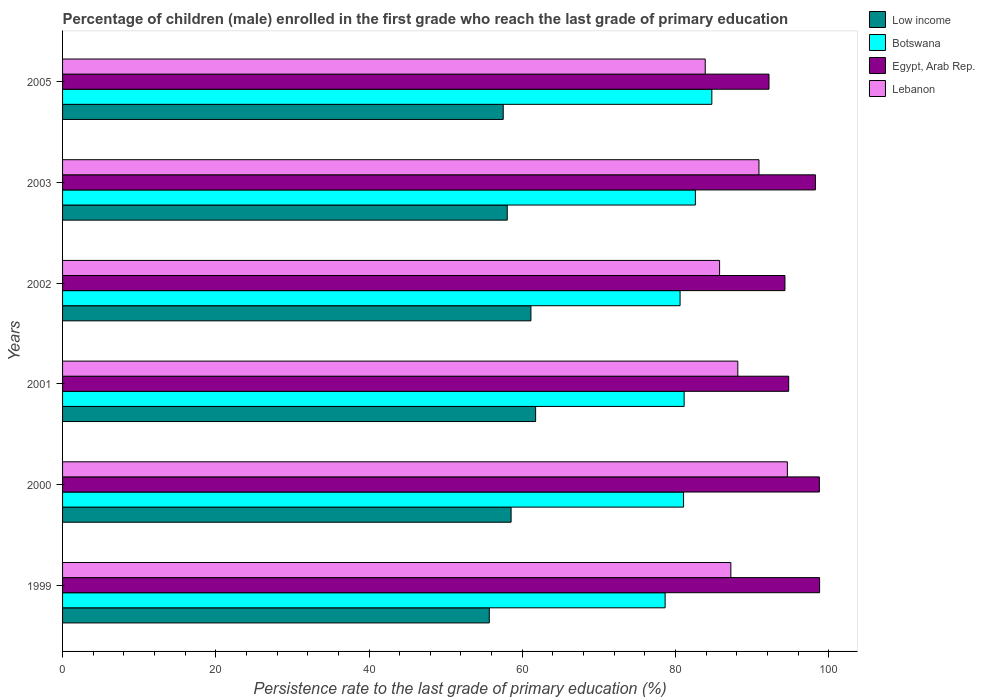How many different coloured bars are there?
Ensure brevity in your answer.  4. Are the number of bars on each tick of the Y-axis equal?
Make the answer very short. Yes. How many bars are there on the 4th tick from the top?
Provide a succinct answer. 4. How many bars are there on the 3rd tick from the bottom?
Your answer should be very brief. 4. In how many cases, is the number of bars for a given year not equal to the number of legend labels?
Offer a terse response. 0. What is the persistence rate of children in Egypt, Arab Rep. in 2000?
Your answer should be compact. 98.78. Across all years, what is the maximum persistence rate of children in Egypt, Arab Rep.?
Make the answer very short. 98.81. Across all years, what is the minimum persistence rate of children in Egypt, Arab Rep.?
Keep it short and to the point. 92.2. In which year was the persistence rate of children in Low income maximum?
Ensure brevity in your answer.  2001. What is the total persistence rate of children in Botswana in the graph?
Your answer should be compact. 488.74. What is the difference between the persistence rate of children in Botswana in 2003 and that in 2005?
Offer a terse response. -2.15. What is the difference between the persistence rate of children in Low income in 2005 and the persistence rate of children in Lebanon in 2000?
Offer a very short reply. -37.09. What is the average persistence rate of children in Egypt, Arab Rep. per year?
Your response must be concise. 96.18. In the year 2000, what is the difference between the persistence rate of children in Low income and persistence rate of children in Egypt, Arab Rep.?
Give a very brief answer. -40.24. What is the ratio of the persistence rate of children in Botswana in 1999 to that in 2001?
Your answer should be very brief. 0.97. What is the difference between the highest and the second highest persistence rate of children in Egypt, Arab Rep.?
Give a very brief answer. 0.03. What is the difference between the highest and the lowest persistence rate of children in Lebanon?
Offer a very short reply. 10.72. In how many years, is the persistence rate of children in Egypt, Arab Rep. greater than the average persistence rate of children in Egypt, Arab Rep. taken over all years?
Your response must be concise. 3. What does the 2nd bar from the top in 2001 represents?
Your response must be concise. Egypt, Arab Rep. What does the 2nd bar from the bottom in 2005 represents?
Provide a short and direct response. Botswana. What is the difference between two consecutive major ticks on the X-axis?
Offer a terse response. 20. Does the graph contain any zero values?
Your answer should be compact. No. How many legend labels are there?
Your response must be concise. 4. What is the title of the graph?
Provide a succinct answer. Percentage of children (male) enrolled in the first grade who reach the last grade of primary education. What is the label or title of the X-axis?
Keep it short and to the point. Persistence rate to the last grade of primary education (%). What is the Persistence rate to the last grade of primary education (%) of Low income in 1999?
Give a very brief answer. 55.7. What is the Persistence rate to the last grade of primary education (%) in Botswana in 1999?
Keep it short and to the point. 78.64. What is the Persistence rate to the last grade of primary education (%) in Egypt, Arab Rep. in 1999?
Give a very brief answer. 98.81. What is the Persistence rate to the last grade of primary education (%) of Lebanon in 1999?
Provide a short and direct response. 87.22. What is the Persistence rate to the last grade of primary education (%) of Low income in 2000?
Make the answer very short. 58.54. What is the Persistence rate to the last grade of primary education (%) of Botswana in 2000?
Provide a succinct answer. 81.05. What is the Persistence rate to the last grade of primary education (%) in Egypt, Arab Rep. in 2000?
Offer a terse response. 98.78. What is the Persistence rate to the last grade of primary education (%) of Lebanon in 2000?
Offer a very short reply. 94.6. What is the Persistence rate to the last grade of primary education (%) of Low income in 2001?
Your answer should be compact. 61.74. What is the Persistence rate to the last grade of primary education (%) of Botswana in 2001?
Offer a terse response. 81.12. What is the Persistence rate to the last grade of primary education (%) in Egypt, Arab Rep. in 2001?
Your response must be concise. 94.77. What is the Persistence rate to the last grade of primary education (%) in Lebanon in 2001?
Give a very brief answer. 88.13. What is the Persistence rate to the last grade of primary education (%) of Low income in 2002?
Give a very brief answer. 61.13. What is the Persistence rate to the last grade of primary education (%) in Botswana in 2002?
Give a very brief answer. 80.59. What is the Persistence rate to the last grade of primary education (%) of Egypt, Arab Rep. in 2002?
Offer a terse response. 94.28. What is the Persistence rate to the last grade of primary education (%) in Lebanon in 2002?
Give a very brief answer. 85.75. What is the Persistence rate to the last grade of primary education (%) of Low income in 2003?
Provide a succinct answer. 58.04. What is the Persistence rate to the last grade of primary education (%) in Botswana in 2003?
Give a very brief answer. 82.59. What is the Persistence rate to the last grade of primary education (%) in Egypt, Arab Rep. in 2003?
Offer a very short reply. 98.26. What is the Persistence rate to the last grade of primary education (%) in Lebanon in 2003?
Offer a terse response. 90.89. What is the Persistence rate to the last grade of primary education (%) of Low income in 2005?
Your answer should be compact. 57.51. What is the Persistence rate to the last grade of primary education (%) of Botswana in 2005?
Offer a terse response. 84.74. What is the Persistence rate to the last grade of primary education (%) of Egypt, Arab Rep. in 2005?
Your answer should be compact. 92.2. What is the Persistence rate to the last grade of primary education (%) in Lebanon in 2005?
Offer a terse response. 83.88. Across all years, what is the maximum Persistence rate to the last grade of primary education (%) in Low income?
Offer a terse response. 61.74. Across all years, what is the maximum Persistence rate to the last grade of primary education (%) in Botswana?
Provide a short and direct response. 84.74. Across all years, what is the maximum Persistence rate to the last grade of primary education (%) in Egypt, Arab Rep.?
Keep it short and to the point. 98.81. Across all years, what is the maximum Persistence rate to the last grade of primary education (%) of Lebanon?
Offer a terse response. 94.6. Across all years, what is the minimum Persistence rate to the last grade of primary education (%) of Low income?
Provide a short and direct response. 55.7. Across all years, what is the minimum Persistence rate to the last grade of primary education (%) of Botswana?
Make the answer very short. 78.64. Across all years, what is the minimum Persistence rate to the last grade of primary education (%) of Egypt, Arab Rep.?
Give a very brief answer. 92.2. Across all years, what is the minimum Persistence rate to the last grade of primary education (%) in Lebanon?
Give a very brief answer. 83.88. What is the total Persistence rate to the last grade of primary education (%) of Low income in the graph?
Your response must be concise. 352.66. What is the total Persistence rate to the last grade of primary education (%) of Botswana in the graph?
Make the answer very short. 488.74. What is the total Persistence rate to the last grade of primary education (%) in Egypt, Arab Rep. in the graph?
Offer a very short reply. 577.1. What is the total Persistence rate to the last grade of primary education (%) of Lebanon in the graph?
Provide a succinct answer. 530.47. What is the difference between the Persistence rate to the last grade of primary education (%) of Low income in 1999 and that in 2000?
Your answer should be compact. -2.84. What is the difference between the Persistence rate to the last grade of primary education (%) in Botswana in 1999 and that in 2000?
Your response must be concise. -2.41. What is the difference between the Persistence rate to the last grade of primary education (%) of Egypt, Arab Rep. in 1999 and that in 2000?
Provide a succinct answer. 0.03. What is the difference between the Persistence rate to the last grade of primary education (%) in Lebanon in 1999 and that in 2000?
Your answer should be compact. -7.38. What is the difference between the Persistence rate to the last grade of primary education (%) in Low income in 1999 and that in 2001?
Your answer should be compact. -6.05. What is the difference between the Persistence rate to the last grade of primary education (%) of Botswana in 1999 and that in 2001?
Your response must be concise. -2.48. What is the difference between the Persistence rate to the last grade of primary education (%) of Egypt, Arab Rep. in 1999 and that in 2001?
Offer a very short reply. 4.04. What is the difference between the Persistence rate to the last grade of primary education (%) in Lebanon in 1999 and that in 2001?
Keep it short and to the point. -0.91. What is the difference between the Persistence rate to the last grade of primary education (%) in Low income in 1999 and that in 2002?
Offer a terse response. -5.43. What is the difference between the Persistence rate to the last grade of primary education (%) of Botswana in 1999 and that in 2002?
Your answer should be very brief. -1.95. What is the difference between the Persistence rate to the last grade of primary education (%) of Egypt, Arab Rep. in 1999 and that in 2002?
Keep it short and to the point. 4.52. What is the difference between the Persistence rate to the last grade of primary education (%) of Lebanon in 1999 and that in 2002?
Your answer should be compact. 1.47. What is the difference between the Persistence rate to the last grade of primary education (%) of Low income in 1999 and that in 2003?
Offer a very short reply. -2.34. What is the difference between the Persistence rate to the last grade of primary education (%) in Botswana in 1999 and that in 2003?
Ensure brevity in your answer.  -3.95. What is the difference between the Persistence rate to the last grade of primary education (%) in Egypt, Arab Rep. in 1999 and that in 2003?
Keep it short and to the point. 0.54. What is the difference between the Persistence rate to the last grade of primary education (%) in Lebanon in 1999 and that in 2003?
Offer a very short reply. -3.67. What is the difference between the Persistence rate to the last grade of primary education (%) in Low income in 1999 and that in 2005?
Offer a very short reply. -1.82. What is the difference between the Persistence rate to the last grade of primary education (%) in Botswana in 1999 and that in 2005?
Your answer should be compact. -6.1. What is the difference between the Persistence rate to the last grade of primary education (%) in Egypt, Arab Rep. in 1999 and that in 2005?
Provide a short and direct response. 6.61. What is the difference between the Persistence rate to the last grade of primary education (%) in Lebanon in 1999 and that in 2005?
Keep it short and to the point. 3.34. What is the difference between the Persistence rate to the last grade of primary education (%) of Low income in 2000 and that in 2001?
Keep it short and to the point. -3.2. What is the difference between the Persistence rate to the last grade of primary education (%) in Botswana in 2000 and that in 2001?
Ensure brevity in your answer.  -0.08. What is the difference between the Persistence rate to the last grade of primary education (%) in Egypt, Arab Rep. in 2000 and that in 2001?
Make the answer very short. 4.01. What is the difference between the Persistence rate to the last grade of primary education (%) in Lebanon in 2000 and that in 2001?
Your answer should be very brief. 6.47. What is the difference between the Persistence rate to the last grade of primary education (%) of Low income in 2000 and that in 2002?
Make the answer very short. -2.59. What is the difference between the Persistence rate to the last grade of primary education (%) in Botswana in 2000 and that in 2002?
Your answer should be compact. 0.45. What is the difference between the Persistence rate to the last grade of primary education (%) of Egypt, Arab Rep. in 2000 and that in 2002?
Make the answer very short. 4.49. What is the difference between the Persistence rate to the last grade of primary education (%) in Lebanon in 2000 and that in 2002?
Your answer should be compact. 8.85. What is the difference between the Persistence rate to the last grade of primary education (%) of Low income in 2000 and that in 2003?
Offer a terse response. 0.5. What is the difference between the Persistence rate to the last grade of primary education (%) in Botswana in 2000 and that in 2003?
Offer a terse response. -1.54. What is the difference between the Persistence rate to the last grade of primary education (%) in Egypt, Arab Rep. in 2000 and that in 2003?
Make the answer very short. 0.52. What is the difference between the Persistence rate to the last grade of primary education (%) of Lebanon in 2000 and that in 2003?
Offer a very short reply. 3.71. What is the difference between the Persistence rate to the last grade of primary education (%) of Low income in 2000 and that in 2005?
Make the answer very short. 1.03. What is the difference between the Persistence rate to the last grade of primary education (%) in Botswana in 2000 and that in 2005?
Offer a terse response. -3.69. What is the difference between the Persistence rate to the last grade of primary education (%) of Egypt, Arab Rep. in 2000 and that in 2005?
Your answer should be compact. 6.58. What is the difference between the Persistence rate to the last grade of primary education (%) in Lebanon in 2000 and that in 2005?
Ensure brevity in your answer.  10.72. What is the difference between the Persistence rate to the last grade of primary education (%) in Low income in 2001 and that in 2002?
Your response must be concise. 0.62. What is the difference between the Persistence rate to the last grade of primary education (%) of Botswana in 2001 and that in 2002?
Ensure brevity in your answer.  0.53. What is the difference between the Persistence rate to the last grade of primary education (%) in Egypt, Arab Rep. in 2001 and that in 2002?
Ensure brevity in your answer.  0.49. What is the difference between the Persistence rate to the last grade of primary education (%) of Lebanon in 2001 and that in 2002?
Offer a very short reply. 2.38. What is the difference between the Persistence rate to the last grade of primary education (%) in Low income in 2001 and that in 2003?
Offer a terse response. 3.7. What is the difference between the Persistence rate to the last grade of primary education (%) of Botswana in 2001 and that in 2003?
Your response must be concise. -1.47. What is the difference between the Persistence rate to the last grade of primary education (%) in Egypt, Arab Rep. in 2001 and that in 2003?
Provide a short and direct response. -3.49. What is the difference between the Persistence rate to the last grade of primary education (%) of Lebanon in 2001 and that in 2003?
Make the answer very short. -2.76. What is the difference between the Persistence rate to the last grade of primary education (%) of Low income in 2001 and that in 2005?
Your answer should be compact. 4.23. What is the difference between the Persistence rate to the last grade of primary education (%) of Botswana in 2001 and that in 2005?
Provide a short and direct response. -3.62. What is the difference between the Persistence rate to the last grade of primary education (%) in Egypt, Arab Rep. in 2001 and that in 2005?
Keep it short and to the point. 2.57. What is the difference between the Persistence rate to the last grade of primary education (%) in Lebanon in 2001 and that in 2005?
Give a very brief answer. 4.25. What is the difference between the Persistence rate to the last grade of primary education (%) of Low income in 2002 and that in 2003?
Your response must be concise. 3.09. What is the difference between the Persistence rate to the last grade of primary education (%) in Botswana in 2002 and that in 2003?
Your answer should be compact. -2. What is the difference between the Persistence rate to the last grade of primary education (%) in Egypt, Arab Rep. in 2002 and that in 2003?
Ensure brevity in your answer.  -3.98. What is the difference between the Persistence rate to the last grade of primary education (%) in Lebanon in 2002 and that in 2003?
Your answer should be very brief. -5.14. What is the difference between the Persistence rate to the last grade of primary education (%) of Low income in 2002 and that in 2005?
Keep it short and to the point. 3.61. What is the difference between the Persistence rate to the last grade of primary education (%) in Botswana in 2002 and that in 2005?
Your response must be concise. -4.15. What is the difference between the Persistence rate to the last grade of primary education (%) of Egypt, Arab Rep. in 2002 and that in 2005?
Ensure brevity in your answer.  2.08. What is the difference between the Persistence rate to the last grade of primary education (%) of Lebanon in 2002 and that in 2005?
Offer a very short reply. 1.87. What is the difference between the Persistence rate to the last grade of primary education (%) of Low income in 2003 and that in 2005?
Your answer should be very brief. 0.53. What is the difference between the Persistence rate to the last grade of primary education (%) in Botswana in 2003 and that in 2005?
Make the answer very short. -2.15. What is the difference between the Persistence rate to the last grade of primary education (%) in Egypt, Arab Rep. in 2003 and that in 2005?
Your response must be concise. 6.06. What is the difference between the Persistence rate to the last grade of primary education (%) of Lebanon in 2003 and that in 2005?
Your answer should be very brief. 7.01. What is the difference between the Persistence rate to the last grade of primary education (%) of Low income in 1999 and the Persistence rate to the last grade of primary education (%) of Botswana in 2000?
Provide a short and direct response. -25.35. What is the difference between the Persistence rate to the last grade of primary education (%) of Low income in 1999 and the Persistence rate to the last grade of primary education (%) of Egypt, Arab Rep. in 2000?
Ensure brevity in your answer.  -43.08. What is the difference between the Persistence rate to the last grade of primary education (%) of Low income in 1999 and the Persistence rate to the last grade of primary education (%) of Lebanon in 2000?
Provide a succinct answer. -38.9. What is the difference between the Persistence rate to the last grade of primary education (%) of Botswana in 1999 and the Persistence rate to the last grade of primary education (%) of Egypt, Arab Rep. in 2000?
Make the answer very short. -20.13. What is the difference between the Persistence rate to the last grade of primary education (%) of Botswana in 1999 and the Persistence rate to the last grade of primary education (%) of Lebanon in 2000?
Your response must be concise. -15.96. What is the difference between the Persistence rate to the last grade of primary education (%) of Egypt, Arab Rep. in 1999 and the Persistence rate to the last grade of primary education (%) of Lebanon in 2000?
Offer a terse response. 4.21. What is the difference between the Persistence rate to the last grade of primary education (%) in Low income in 1999 and the Persistence rate to the last grade of primary education (%) in Botswana in 2001?
Keep it short and to the point. -25.43. What is the difference between the Persistence rate to the last grade of primary education (%) in Low income in 1999 and the Persistence rate to the last grade of primary education (%) in Egypt, Arab Rep. in 2001?
Offer a terse response. -39.07. What is the difference between the Persistence rate to the last grade of primary education (%) in Low income in 1999 and the Persistence rate to the last grade of primary education (%) in Lebanon in 2001?
Your answer should be compact. -32.43. What is the difference between the Persistence rate to the last grade of primary education (%) in Botswana in 1999 and the Persistence rate to the last grade of primary education (%) in Egypt, Arab Rep. in 2001?
Make the answer very short. -16.13. What is the difference between the Persistence rate to the last grade of primary education (%) of Botswana in 1999 and the Persistence rate to the last grade of primary education (%) of Lebanon in 2001?
Give a very brief answer. -9.49. What is the difference between the Persistence rate to the last grade of primary education (%) of Egypt, Arab Rep. in 1999 and the Persistence rate to the last grade of primary education (%) of Lebanon in 2001?
Keep it short and to the point. 10.68. What is the difference between the Persistence rate to the last grade of primary education (%) in Low income in 1999 and the Persistence rate to the last grade of primary education (%) in Botswana in 2002?
Provide a short and direct response. -24.9. What is the difference between the Persistence rate to the last grade of primary education (%) of Low income in 1999 and the Persistence rate to the last grade of primary education (%) of Egypt, Arab Rep. in 2002?
Provide a short and direct response. -38.59. What is the difference between the Persistence rate to the last grade of primary education (%) in Low income in 1999 and the Persistence rate to the last grade of primary education (%) in Lebanon in 2002?
Keep it short and to the point. -30.06. What is the difference between the Persistence rate to the last grade of primary education (%) of Botswana in 1999 and the Persistence rate to the last grade of primary education (%) of Egypt, Arab Rep. in 2002?
Your response must be concise. -15.64. What is the difference between the Persistence rate to the last grade of primary education (%) in Botswana in 1999 and the Persistence rate to the last grade of primary education (%) in Lebanon in 2002?
Offer a very short reply. -7.11. What is the difference between the Persistence rate to the last grade of primary education (%) of Egypt, Arab Rep. in 1999 and the Persistence rate to the last grade of primary education (%) of Lebanon in 2002?
Offer a very short reply. 13.05. What is the difference between the Persistence rate to the last grade of primary education (%) in Low income in 1999 and the Persistence rate to the last grade of primary education (%) in Botswana in 2003?
Give a very brief answer. -26.89. What is the difference between the Persistence rate to the last grade of primary education (%) of Low income in 1999 and the Persistence rate to the last grade of primary education (%) of Egypt, Arab Rep. in 2003?
Ensure brevity in your answer.  -42.57. What is the difference between the Persistence rate to the last grade of primary education (%) in Low income in 1999 and the Persistence rate to the last grade of primary education (%) in Lebanon in 2003?
Offer a terse response. -35.19. What is the difference between the Persistence rate to the last grade of primary education (%) in Botswana in 1999 and the Persistence rate to the last grade of primary education (%) in Egypt, Arab Rep. in 2003?
Your answer should be very brief. -19.62. What is the difference between the Persistence rate to the last grade of primary education (%) in Botswana in 1999 and the Persistence rate to the last grade of primary education (%) in Lebanon in 2003?
Keep it short and to the point. -12.25. What is the difference between the Persistence rate to the last grade of primary education (%) of Egypt, Arab Rep. in 1999 and the Persistence rate to the last grade of primary education (%) of Lebanon in 2003?
Ensure brevity in your answer.  7.92. What is the difference between the Persistence rate to the last grade of primary education (%) in Low income in 1999 and the Persistence rate to the last grade of primary education (%) in Botswana in 2005?
Your answer should be compact. -29.05. What is the difference between the Persistence rate to the last grade of primary education (%) of Low income in 1999 and the Persistence rate to the last grade of primary education (%) of Egypt, Arab Rep. in 2005?
Ensure brevity in your answer.  -36.5. What is the difference between the Persistence rate to the last grade of primary education (%) of Low income in 1999 and the Persistence rate to the last grade of primary education (%) of Lebanon in 2005?
Offer a very short reply. -28.18. What is the difference between the Persistence rate to the last grade of primary education (%) in Botswana in 1999 and the Persistence rate to the last grade of primary education (%) in Egypt, Arab Rep. in 2005?
Make the answer very short. -13.56. What is the difference between the Persistence rate to the last grade of primary education (%) of Botswana in 1999 and the Persistence rate to the last grade of primary education (%) of Lebanon in 2005?
Ensure brevity in your answer.  -5.24. What is the difference between the Persistence rate to the last grade of primary education (%) in Egypt, Arab Rep. in 1999 and the Persistence rate to the last grade of primary education (%) in Lebanon in 2005?
Give a very brief answer. 14.93. What is the difference between the Persistence rate to the last grade of primary education (%) of Low income in 2000 and the Persistence rate to the last grade of primary education (%) of Botswana in 2001?
Make the answer very short. -22.58. What is the difference between the Persistence rate to the last grade of primary education (%) in Low income in 2000 and the Persistence rate to the last grade of primary education (%) in Egypt, Arab Rep. in 2001?
Ensure brevity in your answer.  -36.23. What is the difference between the Persistence rate to the last grade of primary education (%) of Low income in 2000 and the Persistence rate to the last grade of primary education (%) of Lebanon in 2001?
Provide a succinct answer. -29.59. What is the difference between the Persistence rate to the last grade of primary education (%) of Botswana in 2000 and the Persistence rate to the last grade of primary education (%) of Egypt, Arab Rep. in 2001?
Provide a succinct answer. -13.72. What is the difference between the Persistence rate to the last grade of primary education (%) in Botswana in 2000 and the Persistence rate to the last grade of primary education (%) in Lebanon in 2001?
Make the answer very short. -7.08. What is the difference between the Persistence rate to the last grade of primary education (%) in Egypt, Arab Rep. in 2000 and the Persistence rate to the last grade of primary education (%) in Lebanon in 2001?
Make the answer very short. 10.65. What is the difference between the Persistence rate to the last grade of primary education (%) of Low income in 2000 and the Persistence rate to the last grade of primary education (%) of Botswana in 2002?
Keep it short and to the point. -22.05. What is the difference between the Persistence rate to the last grade of primary education (%) of Low income in 2000 and the Persistence rate to the last grade of primary education (%) of Egypt, Arab Rep. in 2002?
Offer a very short reply. -35.74. What is the difference between the Persistence rate to the last grade of primary education (%) of Low income in 2000 and the Persistence rate to the last grade of primary education (%) of Lebanon in 2002?
Offer a terse response. -27.21. What is the difference between the Persistence rate to the last grade of primary education (%) of Botswana in 2000 and the Persistence rate to the last grade of primary education (%) of Egypt, Arab Rep. in 2002?
Provide a succinct answer. -13.23. What is the difference between the Persistence rate to the last grade of primary education (%) of Botswana in 2000 and the Persistence rate to the last grade of primary education (%) of Lebanon in 2002?
Offer a very short reply. -4.7. What is the difference between the Persistence rate to the last grade of primary education (%) of Egypt, Arab Rep. in 2000 and the Persistence rate to the last grade of primary education (%) of Lebanon in 2002?
Your answer should be very brief. 13.02. What is the difference between the Persistence rate to the last grade of primary education (%) in Low income in 2000 and the Persistence rate to the last grade of primary education (%) in Botswana in 2003?
Provide a succinct answer. -24.05. What is the difference between the Persistence rate to the last grade of primary education (%) of Low income in 2000 and the Persistence rate to the last grade of primary education (%) of Egypt, Arab Rep. in 2003?
Offer a terse response. -39.72. What is the difference between the Persistence rate to the last grade of primary education (%) in Low income in 2000 and the Persistence rate to the last grade of primary education (%) in Lebanon in 2003?
Offer a very short reply. -32.35. What is the difference between the Persistence rate to the last grade of primary education (%) in Botswana in 2000 and the Persistence rate to the last grade of primary education (%) in Egypt, Arab Rep. in 2003?
Keep it short and to the point. -17.21. What is the difference between the Persistence rate to the last grade of primary education (%) in Botswana in 2000 and the Persistence rate to the last grade of primary education (%) in Lebanon in 2003?
Give a very brief answer. -9.84. What is the difference between the Persistence rate to the last grade of primary education (%) in Egypt, Arab Rep. in 2000 and the Persistence rate to the last grade of primary education (%) in Lebanon in 2003?
Your response must be concise. 7.89. What is the difference between the Persistence rate to the last grade of primary education (%) of Low income in 2000 and the Persistence rate to the last grade of primary education (%) of Botswana in 2005?
Give a very brief answer. -26.2. What is the difference between the Persistence rate to the last grade of primary education (%) of Low income in 2000 and the Persistence rate to the last grade of primary education (%) of Egypt, Arab Rep. in 2005?
Keep it short and to the point. -33.66. What is the difference between the Persistence rate to the last grade of primary education (%) in Low income in 2000 and the Persistence rate to the last grade of primary education (%) in Lebanon in 2005?
Provide a short and direct response. -25.34. What is the difference between the Persistence rate to the last grade of primary education (%) of Botswana in 2000 and the Persistence rate to the last grade of primary education (%) of Egypt, Arab Rep. in 2005?
Give a very brief answer. -11.15. What is the difference between the Persistence rate to the last grade of primary education (%) in Botswana in 2000 and the Persistence rate to the last grade of primary education (%) in Lebanon in 2005?
Provide a succinct answer. -2.83. What is the difference between the Persistence rate to the last grade of primary education (%) in Egypt, Arab Rep. in 2000 and the Persistence rate to the last grade of primary education (%) in Lebanon in 2005?
Your response must be concise. 14.9. What is the difference between the Persistence rate to the last grade of primary education (%) of Low income in 2001 and the Persistence rate to the last grade of primary education (%) of Botswana in 2002?
Your answer should be compact. -18.85. What is the difference between the Persistence rate to the last grade of primary education (%) of Low income in 2001 and the Persistence rate to the last grade of primary education (%) of Egypt, Arab Rep. in 2002?
Your answer should be compact. -32.54. What is the difference between the Persistence rate to the last grade of primary education (%) of Low income in 2001 and the Persistence rate to the last grade of primary education (%) of Lebanon in 2002?
Your response must be concise. -24.01. What is the difference between the Persistence rate to the last grade of primary education (%) of Botswana in 2001 and the Persistence rate to the last grade of primary education (%) of Egypt, Arab Rep. in 2002?
Provide a short and direct response. -13.16. What is the difference between the Persistence rate to the last grade of primary education (%) in Botswana in 2001 and the Persistence rate to the last grade of primary education (%) in Lebanon in 2002?
Your answer should be compact. -4.63. What is the difference between the Persistence rate to the last grade of primary education (%) in Egypt, Arab Rep. in 2001 and the Persistence rate to the last grade of primary education (%) in Lebanon in 2002?
Your answer should be compact. 9.02. What is the difference between the Persistence rate to the last grade of primary education (%) of Low income in 2001 and the Persistence rate to the last grade of primary education (%) of Botswana in 2003?
Keep it short and to the point. -20.85. What is the difference between the Persistence rate to the last grade of primary education (%) in Low income in 2001 and the Persistence rate to the last grade of primary education (%) in Egypt, Arab Rep. in 2003?
Give a very brief answer. -36.52. What is the difference between the Persistence rate to the last grade of primary education (%) in Low income in 2001 and the Persistence rate to the last grade of primary education (%) in Lebanon in 2003?
Your answer should be very brief. -29.15. What is the difference between the Persistence rate to the last grade of primary education (%) of Botswana in 2001 and the Persistence rate to the last grade of primary education (%) of Egypt, Arab Rep. in 2003?
Make the answer very short. -17.14. What is the difference between the Persistence rate to the last grade of primary education (%) of Botswana in 2001 and the Persistence rate to the last grade of primary education (%) of Lebanon in 2003?
Your answer should be very brief. -9.77. What is the difference between the Persistence rate to the last grade of primary education (%) in Egypt, Arab Rep. in 2001 and the Persistence rate to the last grade of primary education (%) in Lebanon in 2003?
Your answer should be very brief. 3.88. What is the difference between the Persistence rate to the last grade of primary education (%) of Low income in 2001 and the Persistence rate to the last grade of primary education (%) of Botswana in 2005?
Keep it short and to the point. -23. What is the difference between the Persistence rate to the last grade of primary education (%) of Low income in 2001 and the Persistence rate to the last grade of primary education (%) of Egypt, Arab Rep. in 2005?
Your response must be concise. -30.46. What is the difference between the Persistence rate to the last grade of primary education (%) of Low income in 2001 and the Persistence rate to the last grade of primary education (%) of Lebanon in 2005?
Offer a terse response. -22.14. What is the difference between the Persistence rate to the last grade of primary education (%) of Botswana in 2001 and the Persistence rate to the last grade of primary education (%) of Egypt, Arab Rep. in 2005?
Give a very brief answer. -11.08. What is the difference between the Persistence rate to the last grade of primary education (%) of Botswana in 2001 and the Persistence rate to the last grade of primary education (%) of Lebanon in 2005?
Your answer should be very brief. -2.75. What is the difference between the Persistence rate to the last grade of primary education (%) in Egypt, Arab Rep. in 2001 and the Persistence rate to the last grade of primary education (%) in Lebanon in 2005?
Your answer should be compact. 10.89. What is the difference between the Persistence rate to the last grade of primary education (%) of Low income in 2002 and the Persistence rate to the last grade of primary education (%) of Botswana in 2003?
Your response must be concise. -21.46. What is the difference between the Persistence rate to the last grade of primary education (%) of Low income in 2002 and the Persistence rate to the last grade of primary education (%) of Egypt, Arab Rep. in 2003?
Offer a very short reply. -37.13. What is the difference between the Persistence rate to the last grade of primary education (%) of Low income in 2002 and the Persistence rate to the last grade of primary education (%) of Lebanon in 2003?
Offer a terse response. -29.76. What is the difference between the Persistence rate to the last grade of primary education (%) of Botswana in 2002 and the Persistence rate to the last grade of primary education (%) of Egypt, Arab Rep. in 2003?
Keep it short and to the point. -17.67. What is the difference between the Persistence rate to the last grade of primary education (%) of Botswana in 2002 and the Persistence rate to the last grade of primary education (%) of Lebanon in 2003?
Provide a short and direct response. -10.3. What is the difference between the Persistence rate to the last grade of primary education (%) in Egypt, Arab Rep. in 2002 and the Persistence rate to the last grade of primary education (%) in Lebanon in 2003?
Your answer should be compact. 3.39. What is the difference between the Persistence rate to the last grade of primary education (%) in Low income in 2002 and the Persistence rate to the last grade of primary education (%) in Botswana in 2005?
Keep it short and to the point. -23.61. What is the difference between the Persistence rate to the last grade of primary education (%) in Low income in 2002 and the Persistence rate to the last grade of primary education (%) in Egypt, Arab Rep. in 2005?
Offer a terse response. -31.07. What is the difference between the Persistence rate to the last grade of primary education (%) of Low income in 2002 and the Persistence rate to the last grade of primary education (%) of Lebanon in 2005?
Keep it short and to the point. -22.75. What is the difference between the Persistence rate to the last grade of primary education (%) in Botswana in 2002 and the Persistence rate to the last grade of primary education (%) in Egypt, Arab Rep. in 2005?
Your answer should be compact. -11.61. What is the difference between the Persistence rate to the last grade of primary education (%) in Botswana in 2002 and the Persistence rate to the last grade of primary education (%) in Lebanon in 2005?
Give a very brief answer. -3.28. What is the difference between the Persistence rate to the last grade of primary education (%) of Egypt, Arab Rep. in 2002 and the Persistence rate to the last grade of primary education (%) of Lebanon in 2005?
Make the answer very short. 10.4. What is the difference between the Persistence rate to the last grade of primary education (%) in Low income in 2003 and the Persistence rate to the last grade of primary education (%) in Botswana in 2005?
Provide a short and direct response. -26.7. What is the difference between the Persistence rate to the last grade of primary education (%) of Low income in 2003 and the Persistence rate to the last grade of primary education (%) of Egypt, Arab Rep. in 2005?
Give a very brief answer. -34.16. What is the difference between the Persistence rate to the last grade of primary education (%) of Low income in 2003 and the Persistence rate to the last grade of primary education (%) of Lebanon in 2005?
Provide a succinct answer. -25.84. What is the difference between the Persistence rate to the last grade of primary education (%) of Botswana in 2003 and the Persistence rate to the last grade of primary education (%) of Egypt, Arab Rep. in 2005?
Your answer should be compact. -9.61. What is the difference between the Persistence rate to the last grade of primary education (%) of Botswana in 2003 and the Persistence rate to the last grade of primary education (%) of Lebanon in 2005?
Your response must be concise. -1.29. What is the difference between the Persistence rate to the last grade of primary education (%) in Egypt, Arab Rep. in 2003 and the Persistence rate to the last grade of primary education (%) in Lebanon in 2005?
Your answer should be compact. 14.38. What is the average Persistence rate to the last grade of primary education (%) in Low income per year?
Keep it short and to the point. 58.78. What is the average Persistence rate to the last grade of primary education (%) of Botswana per year?
Provide a short and direct response. 81.46. What is the average Persistence rate to the last grade of primary education (%) of Egypt, Arab Rep. per year?
Give a very brief answer. 96.18. What is the average Persistence rate to the last grade of primary education (%) of Lebanon per year?
Your answer should be very brief. 88.41. In the year 1999, what is the difference between the Persistence rate to the last grade of primary education (%) in Low income and Persistence rate to the last grade of primary education (%) in Botswana?
Keep it short and to the point. -22.95. In the year 1999, what is the difference between the Persistence rate to the last grade of primary education (%) of Low income and Persistence rate to the last grade of primary education (%) of Egypt, Arab Rep.?
Offer a terse response. -43.11. In the year 1999, what is the difference between the Persistence rate to the last grade of primary education (%) of Low income and Persistence rate to the last grade of primary education (%) of Lebanon?
Offer a terse response. -31.53. In the year 1999, what is the difference between the Persistence rate to the last grade of primary education (%) of Botswana and Persistence rate to the last grade of primary education (%) of Egypt, Arab Rep.?
Give a very brief answer. -20.16. In the year 1999, what is the difference between the Persistence rate to the last grade of primary education (%) in Botswana and Persistence rate to the last grade of primary education (%) in Lebanon?
Your response must be concise. -8.58. In the year 1999, what is the difference between the Persistence rate to the last grade of primary education (%) in Egypt, Arab Rep. and Persistence rate to the last grade of primary education (%) in Lebanon?
Offer a terse response. 11.58. In the year 2000, what is the difference between the Persistence rate to the last grade of primary education (%) in Low income and Persistence rate to the last grade of primary education (%) in Botswana?
Offer a very short reply. -22.51. In the year 2000, what is the difference between the Persistence rate to the last grade of primary education (%) in Low income and Persistence rate to the last grade of primary education (%) in Egypt, Arab Rep.?
Ensure brevity in your answer.  -40.24. In the year 2000, what is the difference between the Persistence rate to the last grade of primary education (%) of Low income and Persistence rate to the last grade of primary education (%) of Lebanon?
Offer a terse response. -36.06. In the year 2000, what is the difference between the Persistence rate to the last grade of primary education (%) of Botswana and Persistence rate to the last grade of primary education (%) of Egypt, Arab Rep.?
Ensure brevity in your answer.  -17.73. In the year 2000, what is the difference between the Persistence rate to the last grade of primary education (%) of Botswana and Persistence rate to the last grade of primary education (%) of Lebanon?
Your answer should be very brief. -13.55. In the year 2000, what is the difference between the Persistence rate to the last grade of primary education (%) of Egypt, Arab Rep. and Persistence rate to the last grade of primary education (%) of Lebanon?
Your answer should be compact. 4.18. In the year 2001, what is the difference between the Persistence rate to the last grade of primary education (%) of Low income and Persistence rate to the last grade of primary education (%) of Botswana?
Provide a succinct answer. -19.38. In the year 2001, what is the difference between the Persistence rate to the last grade of primary education (%) in Low income and Persistence rate to the last grade of primary education (%) in Egypt, Arab Rep.?
Ensure brevity in your answer.  -33.03. In the year 2001, what is the difference between the Persistence rate to the last grade of primary education (%) in Low income and Persistence rate to the last grade of primary education (%) in Lebanon?
Offer a very short reply. -26.39. In the year 2001, what is the difference between the Persistence rate to the last grade of primary education (%) in Botswana and Persistence rate to the last grade of primary education (%) in Egypt, Arab Rep.?
Offer a very short reply. -13.65. In the year 2001, what is the difference between the Persistence rate to the last grade of primary education (%) of Botswana and Persistence rate to the last grade of primary education (%) of Lebanon?
Keep it short and to the point. -7.01. In the year 2001, what is the difference between the Persistence rate to the last grade of primary education (%) in Egypt, Arab Rep. and Persistence rate to the last grade of primary education (%) in Lebanon?
Offer a terse response. 6.64. In the year 2002, what is the difference between the Persistence rate to the last grade of primary education (%) of Low income and Persistence rate to the last grade of primary education (%) of Botswana?
Offer a very short reply. -19.47. In the year 2002, what is the difference between the Persistence rate to the last grade of primary education (%) in Low income and Persistence rate to the last grade of primary education (%) in Egypt, Arab Rep.?
Provide a short and direct response. -33.16. In the year 2002, what is the difference between the Persistence rate to the last grade of primary education (%) in Low income and Persistence rate to the last grade of primary education (%) in Lebanon?
Offer a very short reply. -24.63. In the year 2002, what is the difference between the Persistence rate to the last grade of primary education (%) of Botswana and Persistence rate to the last grade of primary education (%) of Egypt, Arab Rep.?
Provide a short and direct response. -13.69. In the year 2002, what is the difference between the Persistence rate to the last grade of primary education (%) of Botswana and Persistence rate to the last grade of primary education (%) of Lebanon?
Offer a terse response. -5.16. In the year 2002, what is the difference between the Persistence rate to the last grade of primary education (%) in Egypt, Arab Rep. and Persistence rate to the last grade of primary education (%) in Lebanon?
Give a very brief answer. 8.53. In the year 2003, what is the difference between the Persistence rate to the last grade of primary education (%) of Low income and Persistence rate to the last grade of primary education (%) of Botswana?
Your answer should be very brief. -24.55. In the year 2003, what is the difference between the Persistence rate to the last grade of primary education (%) of Low income and Persistence rate to the last grade of primary education (%) of Egypt, Arab Rep.?
Ensure brevity in your answer.  -40.22. In the year 2003, what is the difference between the Persistence rate to the last grade of primary education (%) in Low income and Persistence rate to the last grade of primary education (%) in Lebanon?
Make the answer very short. -32.85. In the year 2003, what is the difference between the Persistence rate to the last grade of primary education (%) in Botswana and Persistence rate to the last grade of primary education (%) in Egypt, Arab Rep.?
Your answer should be compact. -15.67. In the year 2003, what is the difference between the Persistence rate to the last grade of primary education (%) of Botswana and Persistence rate to the last grade of primary education (%) of Lebanon?
Provide a short and direct response. -8.3. In the year 2003, what is the difference between the Persistence rate to the last grade of primary education (%) in Egypt, Arab Rep. and Persistence rate to the last grade of primary education (%) in Lebanon?
Provide a short and direct response. 7.37. In the year 2005, what is the difference between the Persistence rate to the last grade of primary education (%) of Low income and Persistence rate to the last grade of primary education (%) of Botswana?
Offer a terse response. -27.23. In the year 2005, what is the difference between the Persistence rate to the last grade of primary education (%) in Low income and Persistence rate to the last grade of primary education (%) in Egypt, Arab Rep.?
Ensure brevity in your answer.  -34.69. In the year 2005, what is the difference between the Persistence rate to the last grade of primary education (%) of Low income and Persistence rate to the last grade of primary education (%) of Lebanon?
Keep it short and to the point. -26.37. In the year 2005, what is the difference between the Persistence rate to the last grade of primary education (%) in Botswana and Persistence rate to the last grade of primary education (%) in Egypt, Arab Rep.?
Your answer should be compact. -7.46. In the year 2005, what is the difference between the Persistence rate to the last grade of primary education (%) of Botswana and Persistence rate to the last grade of primary education (%) of Lebanon?
Provide a succinct answer. 0.86. In the year 2005, what is the difference between the Persistence rate to the last grade of primary education (%) in Egypt, Arab Rep. and Persistence rate to the last grade of primary education (%) in Lebanon?
Give a very brief answer. 8.32. What is the ratio of the Persistence rate to the last grade of primary education (%) in Low income in 1999 to that in 2000?
Provide a short and direct response. 0.95. What is the ratio of the Persistence rate to the last grade of primary education (%) in Botswana in 1999 to that in 2000?
Your answer should be compact. 0.97. What is the ratio of the Persistence rate to the last grade of primary education (%) of Lebanon in 1999 to that in 2000?
Your answer should be compact. 0.92. What is the ratio of the Persistence rate to the last grade of primary education (%) in Low income in 1999 to that in 2001?
Provide a short and direct response. 0.9. What is the ratio of the Persistence rate to the last grade of primary education (%) of Botswana in 1999 to that in 2001?
Make the answer very short. 0.97. What is the ratio of the Persistence rate to the last grade of primary education (%) of Egypt, Arab Rep. in 1999 to that in 2001?
Keep it short and to the point. 1.04. What is the ratio of the Persistence rate to the last grade of primary education (%) in Low income in 1999 to that in 2002?
Ensure brevity in your answer.  0.91. What is the ratio of the Persistence rate to the last grade of primary education (%) in Botswana in 1999 to that in 2002?
Your response must be concise. 0.98. What is the ratio of the Persistence rate to the last grade of primary education (%) in Egypt, Arab Rep. in 1999 to that in 2002?
Give a very brief answer. 1.05. What is the ratio of the Persistence rate to the last grade of primary education (%) of Lebanon in 1999 to that in 2002?
Provide a short and direct response. 1.02. What is the ratio of the Persistence rate to the last grade of primary education (%) of Low income in 1999 to that in 2003?
Your answer should be compact. 0.96. What is the ratio of the Persistence rate to the last grade of primary education (%) of Botswana in 1999 to that in 2003?
Your response must be concise. 0.95. What is the ratio of the Persistence rate to the last grade of primary education (%) of Lebanon in 1999 to that in 2003?
Your answer should be very brief. 0.96. What is the ratio of the Persistence rate to the last grade of primary education (%) of Low income in 1999 to that in 2005?
Offer a terse response. 0.97. What is the ratio of the Persistence rate to the last grade of primary education (%) of Botswana in 1999 to that in 2005?
Your response must be concise. 0.93. What is the ratio of the Persistence rate to the last grade of primary education (%) of Egypt, Arab Rep. in 1999 to that in 2005?
Keep it short and to the point. 1.07. What is the ratio of the Persistence rate to the last grade of primary education (%) in Lebanon in 1999 to that in 2005?
Your answer should be compact. 1.04. What is the ratio of the Persistence rate to the last grade of primary education (%) in Low income in 2000 to that in 2001?
Ensure brevity in your answer.  0.95. What is the ratio of the Persistence rate to the last grade of primary education (%) of Botswana in 2000 to that in 2001?
Your answer should be compact. 1. What is the ratio of the Persistence rate to the last grade of primary education (%) in Egypt, Arab Rep. in 2000 to that in 2001?
Make the answer very short. 1.04. What is the ratio of the Persistence rate to the last grade of primary education (%) of Lebanon in 2000 to that in 2001?
Your answer should be very brief. 1.07. What is the ratio of the Persistence rate to the last grade of primary education (%) in Low income in 2000 to that in 2002?
Your response must be concise. 0.96. What is the ratio of the Persistence rate to the last grade of primary education (%) of Botswana in 2000 to that in 2002?
Provide a short and direct response. 1.01. What is the ratio of the Persistence rate to the last grade of primary education (%) in Egypt, Arab Rep. in 2000 to that in 2002?
Ensure brevity in your answer.  1.05. What is the ratio of the Persistence rate to the last grade of primary education (%) in Lebanon in 2000 to that in 2002?
Offer a terse response. 1.1. What is the ratio of the Persistence rate to the last grade of primary education (%) of Low income in 2000 to that in 2003?
Keep it short and to the point. 1.01. What is the ratio of the Persistence rate to the last grade of primary education (%) of Botswana in 2000 to that in 2003?
Keep it short and to the point. 0.98. What is the ratio of the Persistence rate to the last grade of primary education (%) of Egypt, Arab Rep. in 2000 to that in 2003?
Provide a short and direct response. 1.01. What is the ratio of the Persistence rate to the last grade of primary education (%) of Lebanon in 2000 to that in 2003?
Provide a succinct answer. 1.04. What is the ratio of the Persistence rate to the last grade of primary education (%) in Low income in 2000 to that in 2005?
Provide a succinct answer. 1.02. What is the ratio of the Persistence rate to the last grade of primary education (%) of Botswana in 2000 to that in 2005?
Your answer should be very brief. 0.96. What is the ratio of the Persistence rate to the last grade of primary education (%) in Egypt, Arab Rep. in 2000 to that in 2005?
Your response must be concise. 1.07. What is the ratio of the Persistence rate to the last grade of primary education (%) of Lebanon in 2000 to that in 2005?
Give a very brief answer. 1.13. What is the ratio of the Persistence rate to the last grade of primary education (%) in Low income in 2001 to that in 2002?
Offer a terse response. 1.01. What is the ratio of the Persistence rate to the last grade of primary education (%) in Botswana in 2001 to that in 2002?
Give a very brief answer. 1.01. What is the ratio of the Persistence rate to the last grade of primary education (%) in Lebanon in 2001 to that in 2002?
Give a very brief answer. 1.03. What is the ratio of the Persistence rate to the last grade of primary education (%) in Low income in 2001 to that in 2003?
Make the answer very short. 1.06. What is the ratio of the Persistence rate to the last grade of primary education (%) of Botswana in 2001 to that in 2003?
Your answer should be compact. 0.98. What is the ratio of the Persistence rate to the last grade of primary education (%) in Egypt, Arab Rep. in 2001 to that in 2003?
Provide a short and direct response. 0.96. What is the ratio of the Persistence rate to the last grade of primary education (%) of Lebanon in 2001 to that in 2003?
Your answer should be very brief. 0.97. What is the ratio of the Persistence rate to the last grade of primary education (%) of Low income in 2001 to that in 2005?
Give a very brief answer. 1.07. What is the ratio of the Persistence rate to the last grade of primary education (%) in Botswana in 2001 to that in 2005?
Offer a terse response. 0.96. What is the ratio of the Persistence rate to the last grade of primary education (%) in Egypt, Arab Rep. in 2001 to that in 2005?
Offer a very short reply. 1.03. What is the ratio of the Persistence rate to the last grade of primary education (%) of Lebanon in 2001 to that in 2005?
Your answer should be very brief. 1.05. What is the ratio of the Persistence rate to the last grade of primary education (%) of Low income in 2002 to that in 2003?
Provide a short and direct response. 1.05. What is the ratio of the Persistence rate to the last grade of primary education (%) in Botswana in 2002 to that in 2003?
Keep it short and to the point. 0.98. What is the ratio of the Persistence rate to the last grade of primary education (%) in Egypt, Arab Rep. in 2002 to that in 2003?
Provide a succinct answer. 0.96. What is the ratio of the Persistence rate to the last grade of primary education (%) of Lebanon in 2002 to that in 2003?
Your response must be concise. 0.94. What is the ratio of the Persistence rate to the last grade of primary education (%) in Low income in 2002 to that in 2005?
Make the answer very short. 1.06. What is the ratio of the Persistence rate to the last grade of primary education (%) of Botswana in 2002 to that in 2005?
Ensure brevity in your answer.  0.95. What is the ratio of the Persistence rate to the last grade of primary education (%) of Egypt, Arab Rep. in 2002 to that in 2005?
Provide a short and direct response. 1.02. What is the ratio of the Persistence rate to the last grade of primary education (%) of Lebanon in 2002 to that in 2005?
Your answer should be very brief. 1.02. What is the ratio of the Persistence rate to the last grade of primary education (%) in Low income in 2003 to that in 2005?
Make the answer very short. 1.01. What is the ratio of the Persistence rate to the last grade of primary education (%) in Botswana in 2003 to that in 2005?
Offer a terse response. 0.97. What is the ratio of the Persistence rate to the last grade of primary education (%) of Egypt, Arab Rep. in 2003 to that in 2005?
Keep it short and to the point. 1.07. What is the ratio of the Persistence rate to the last grade of primary education (%) in Lebanon in 2003 to that in 2005?
Offer a terse response. 1.08. What is the difference between the highest and the second highest Persistence rate to the last grade of primary education (%) in Low income?
Give a very brief answer. 0.62. What is the difference between the highest and the second highest Persistence rate to the last grade of primary education (%) of Botswana?
Your answer should be compact. 2.15. What is the difference between the highest and the second highest Persistence rate to the last grade of primary education (%) of Egypt, Arab Rep.?
Your response must be concise. 0.03. What is the difference between the highest and the second highest Persistence rate to the last grade of primary education (%) of Lebanon?
Provide a succinct answer. 3.71. What is the difference between the highest and the lowest Persistence rate to the last grade of primary education (%) in Low income?
Provide a succinct answer. 6.05. What is the difference between the highest and the lowest Persistence rate to the last grade of primary education (%) in Botswana?
Provide a short and direct response. 6.1. What is the difference between the highest and the lowest Persistence rate to the last grade of primary education (%) in Egypt, Arab Rep.?
Your response must be concise. 6.61. What is the difference between the highest and the lowest Persistence rate to the last grade of primary education (%) in Lebanon?
Make the answer very short. 10.72. 